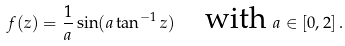Convert formula to latex. <formula><loc_0><loc_0><loc_500><loc_500>f ( z ) = \frac { 1 } { a } \sin ( a \tan ^ { - 1 } z ) \quad \text {with } a \in [ 0 , 2 ] \, .</formula> 